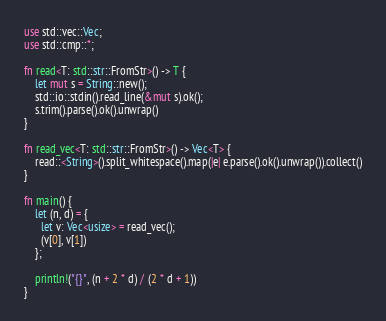Convert code to text. <code><loc_0><loc_0><loc_500><loc_500><_Rust_>use std::vec::Vec;
use std::cmp::*;

fn read<T: std::str::FromStr>() -> T {
    let mut s = String::new();
    std::io::stdin().read_line(&mut s).ok();
    s.trim().parse().ok().unwrap()
}

fn read_vec<T: std::str::FromStr>() -> Vec<T> {
    read::<String>().split_whitespace().map(|e| e.parse().ok().unwrap()).collect()
}

fn main() {
    let (n, d) = {
      let v: Vec<usize> = read_vec();
      (v[0], v[1])
    };

    println!("{}", (n + 2 * d) / (2 * d + 1))
}
</code> 